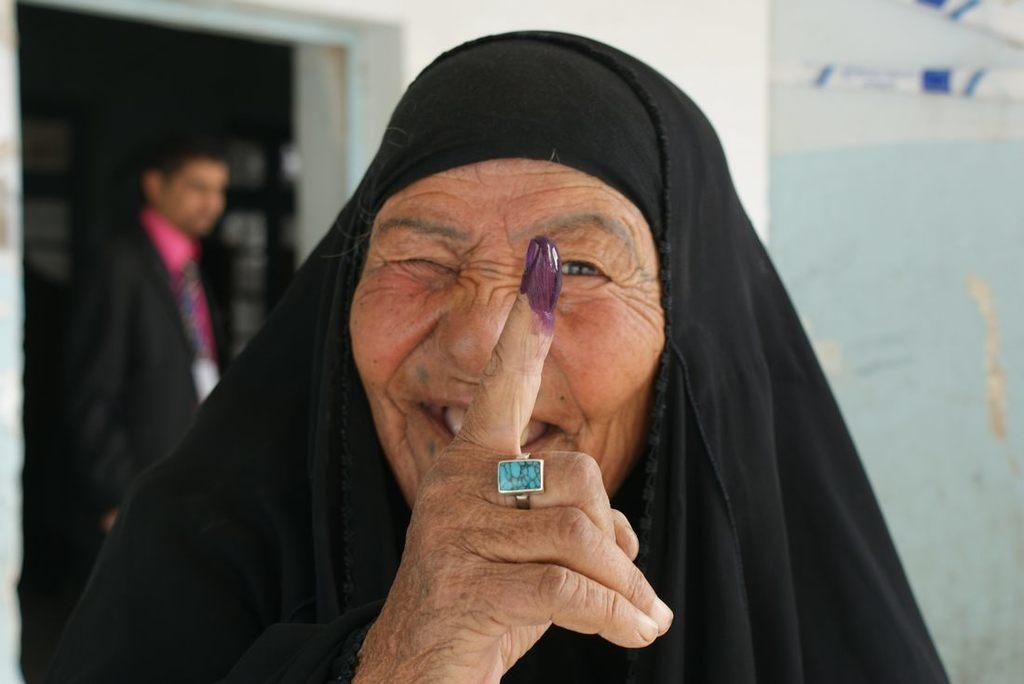Who is the main subject in the image? There is an old woman in the image. What is the old woman wearing? The old woman is wearing a black dress. Can you describe the person on the left side of the image? Unfortunately, the facts provided do not give any information about the person on the left side of the image. What can be seen in the background of the image? There is a wall in the background of the image. What type of potato is being used as a unit of measurement in the image? There is no potato or unit of measurement present in the image. 